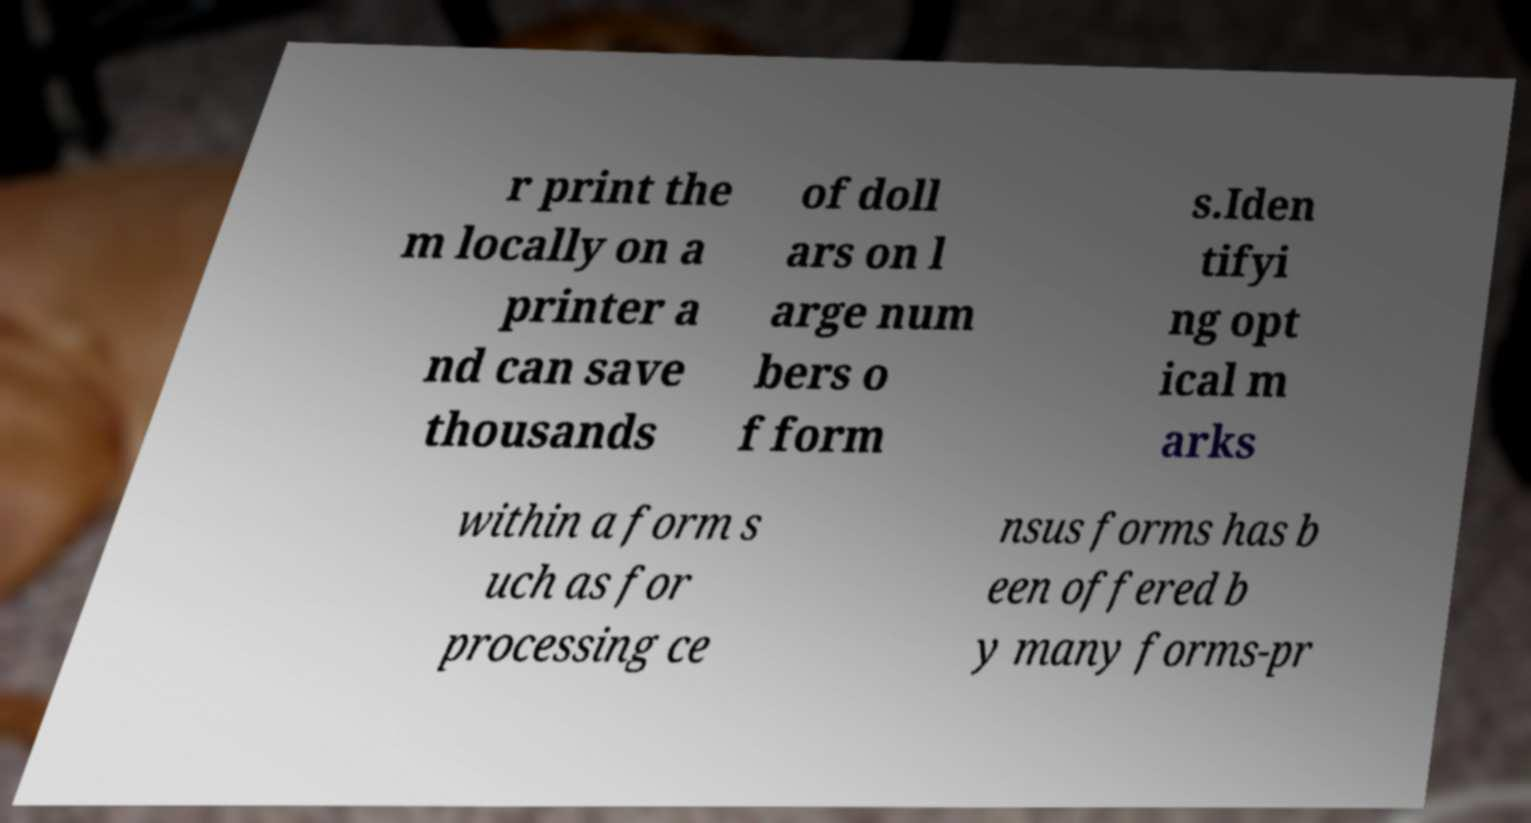Can you read and provide the text displayed in the image?This photo seems to have some interesting text. Can you extract and type it out for me? r print the m locally on a printer a nd can save thousands of doll ars on l arge num bers o f form s.Iden tifyi ng opt ical m arks within a form s uch as for processing ce nsus forms has b een offered b y many forms-pr 